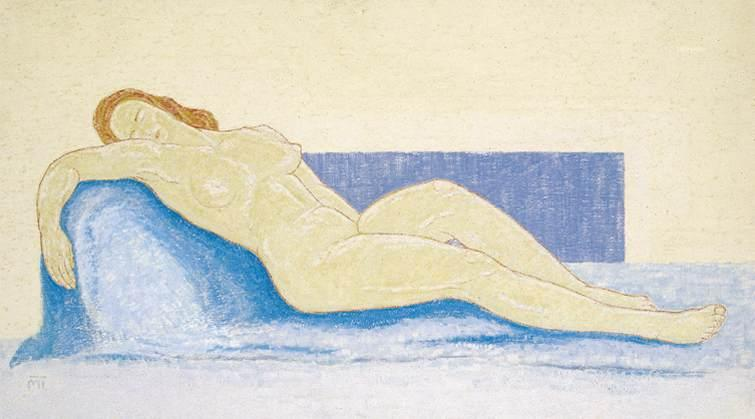Please explain the choice of colors used in this drawing and how they contribute to the overall mood of the artwork. The artist has chosen a palette of soft pastels primarily focusing on pale yellows and various shades of blue. These choices convey a sense of calm and serenity. The blue, used for the couch, symbolizes stability and depth, providing a cool contrast to the warm skin tones of the nude figure. The pale yellow background suggests lightness and airiness, enhancing the tranquil and somewhat introspective mood of the piece. Such a color scheme is typical of impressionistic art, aiming to evoke emotional responses through visual harmony. 